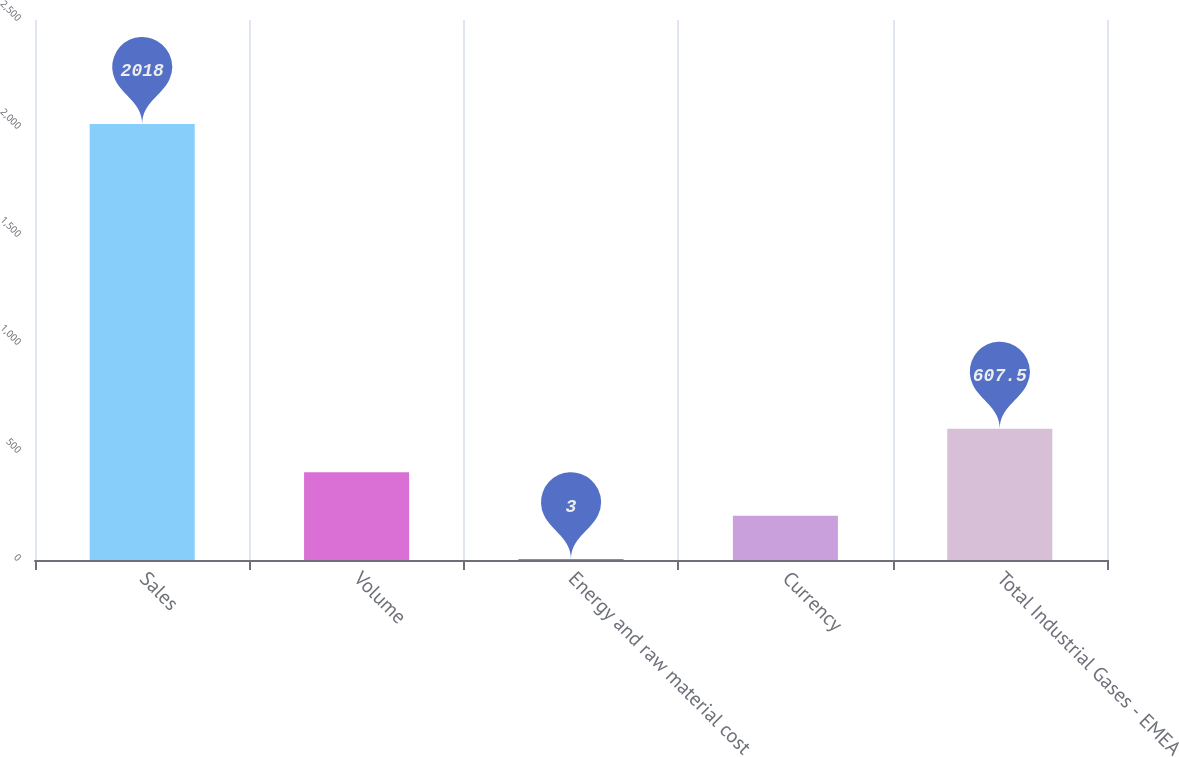Convert chart to OTSL. <chart><loc_0><loc_0><loc_500><loc_500><bar_chart><fcel>Sales<fcel>Volume<fcel>Energy and raw material cost<fcel>Currency<fcel>Total Industrial Gases - EMEA<nl><fcel>2018<fcel>406<fcel>3<fcel>204.5<fcel>607.5<nl></chart> 